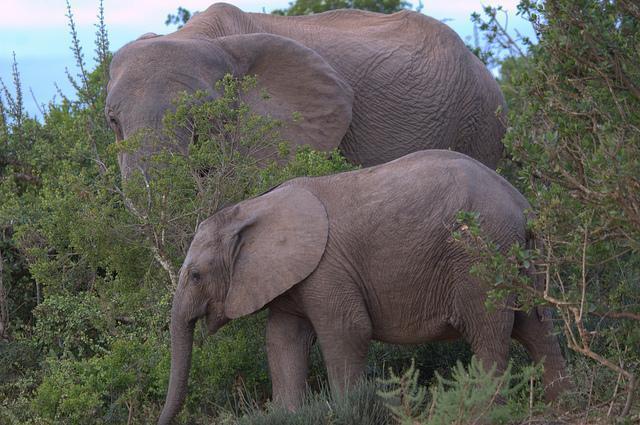How many elephants are here?
Give a very brief answer. 2. How many elephants are there?
Give a very brief answer. 3. How many people are wearing sunglasses in this photo?
Give a very brief answer. 0. 